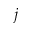<formula> <loc_0><loc_0><loc_500><loc_500>j</formula> 